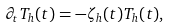Convert formula to latex. <formula><loc_0><loc_0><loc_500><loc_500>\partial _ { t } T _ { h } ( t ) = - \zeta _ { h } ( t ) T _ { h } ( t ) ,</formula> 